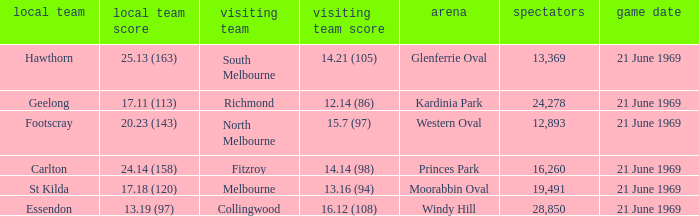What is Essendon's home team that has an away crowd size larger than 19,491? Collingwood. 